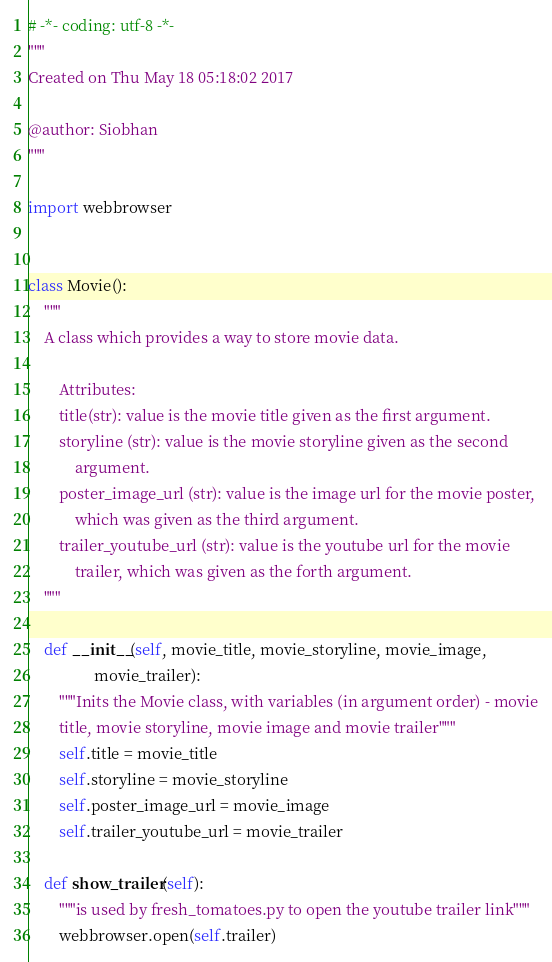<code> <loc_0><loc_0><loc_500><loc_500><_Python_># -*- coding: utf-8 -*-
"""
Created on Thu May 18 05:18:02 2017

@author: Siobhan
"""

import webbrowser


class Movie():
    """
    A class which provides a way to store movie data.

        Attributes:
        title(str): value is the movie title given as the first argument.
        storyline (str): value is the movie storyline given as the second
            argument.
        poster_image_url (str): value is the image url for the movie poster,
            which was given as the third argument.
        trailer_youtube_url (str): value is the youtube url for the movie
            trailer, which was given as the forth argument.
    """

    def __init__(self, movie_title, movie_storyline, movie_image,
                 movie_trailer):
        """Inits the Movie class, with variables (in argument order) - movie
        title, movie storyline, movie image and movie trailer"""
        self.title = movie_title
        self.storyline = movie_storyline
        self.poster_image_url = movie_image
        self.trailer_youtube_url = movie_trailer

    def show_trailer(self):
        """is used by fresh_tomatoes.py to open the youtube trailer link"""
        webbrowser.open(self.trailer)
</code> 